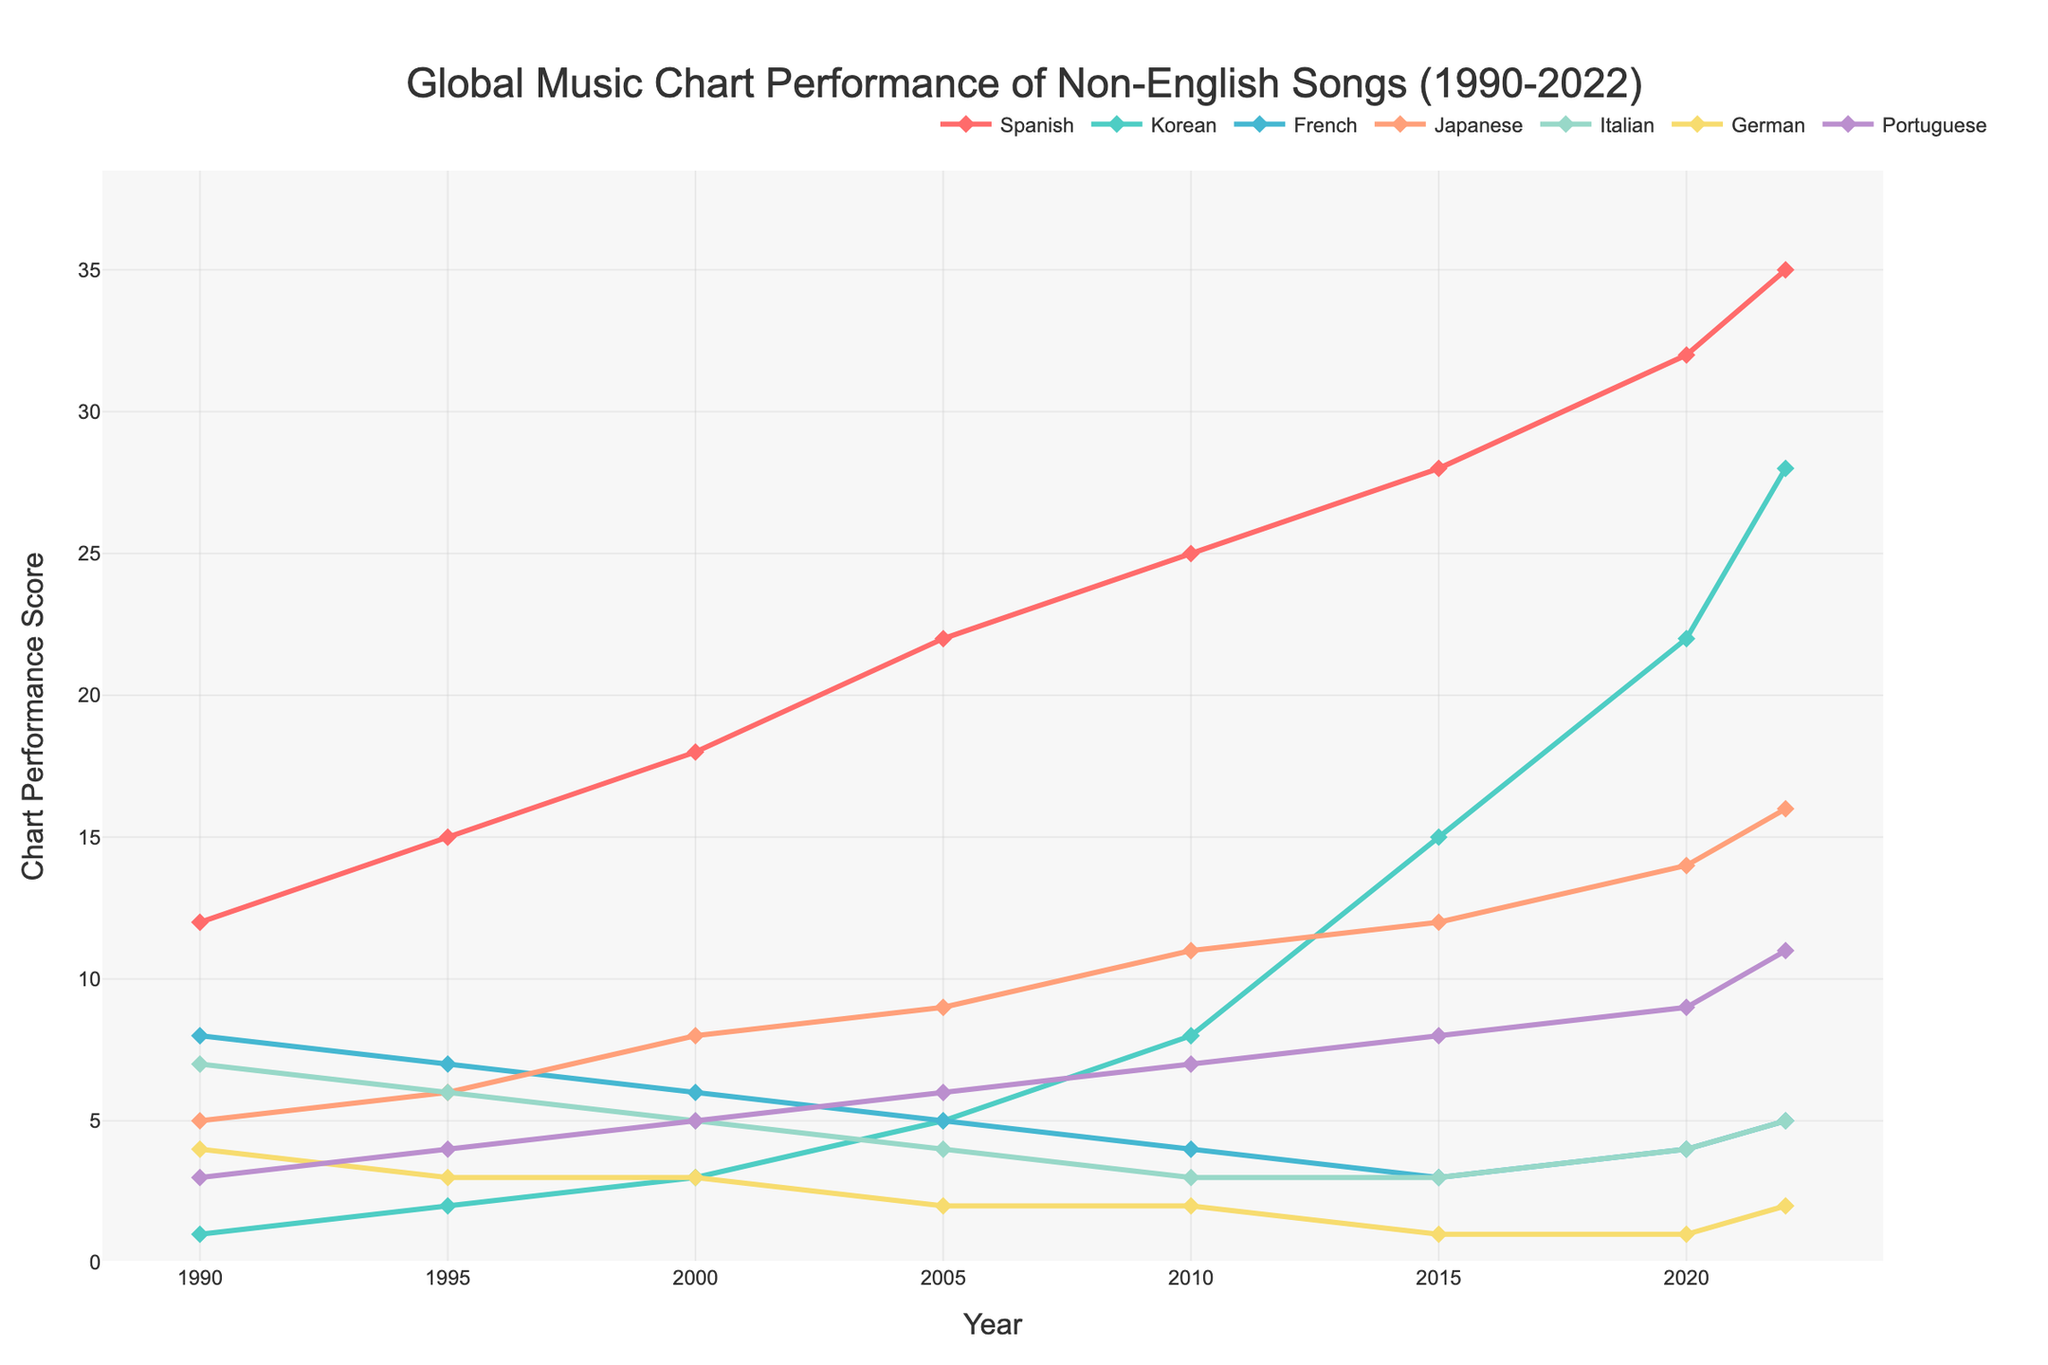What's the difference in the chart performance score for Spanish songs between 1990 and 2022? To find the difference, subtract the chart performance score for Spanish songs in 1990 (12) from the score in 2022 (35). 35 - 12 = 23
Answer: 23 Which language saw the most significant increase in chart performance scores from 1990 to 2022? Compare the scores for all languages between 1990 and 2022. Spanish increased from 12 to 35 (+23), Korean from 1 to 28 (+27), French from 8 to 5 (-3), Japanese from 5 to 16 (+11), Italian from 7 to 5 (-2), German from 4 to 2 (-2), Portuguese from 3 to 11 (+8). Korean had the largest increase.
Answer: Korean Which language consistently had the lowest chart performance score from 1990 to 2022? Check each year's data to identify the language that had the lowest score each year. German had the lowest in 2005, 2010, 2015, and 2020, and Portuguese in 2020, suggesting Portuguese as the consistent lowest in other years.
Answer: German In which year did Japanese songs surpass French songs in chart performance score? Identify and compare the year-wise chart performance scores. In 2000, French scored 6, and Japanese scored 8; from this point onwards, Japanese surpasses French consistently.
Answer: 2000 Which two languages had chart performance scores closest to each other in 2022? Compare the performance scores for all languages in 2022. Spanish: 35, Korean: 28, French: 5, Japanese: 16, Italian: 5, German: 2, Portuguese: 11. The closest scores are French and Italian, both at 5.
Answer: French and Italian How many languages saw a decline in chart performance scores from 1990 to 2022? Compare the initial (1990) and final (2022) scores for all languages. French decreased from 8 to 5, Italian from 7 to 5, German from 4 to 2. Thus, three languages saw a decline.
Answer: Three Was the increase in chart performance score for Portuguese songs between 1995 to 2022 greater than for French songs? Calculate the increase for both: Portuguese: 1995 to 2022 (11 - 4 = 7) and French: 1995 to 2022 (5 - 7 = -2). Portuguese had a greater increase by 7 points.
Answer: Yes In what year did Korean songs have their chart performance score equal to or greater than 15 for the first time? Look for the year where Korean reaches or exceeds a score of 15. In 2015, Korean's score was 15.
Answer: 2015 What is the average chart performance score across all languages in 2005? Add the scores of all languages for the year 2005 (22 + 5 + 5 + 9 + 4 + 2 + 6) and divide by the number of languages (7). The sum is 53, so the average is 53 / 7 = 7.57
Answer: 7.57 